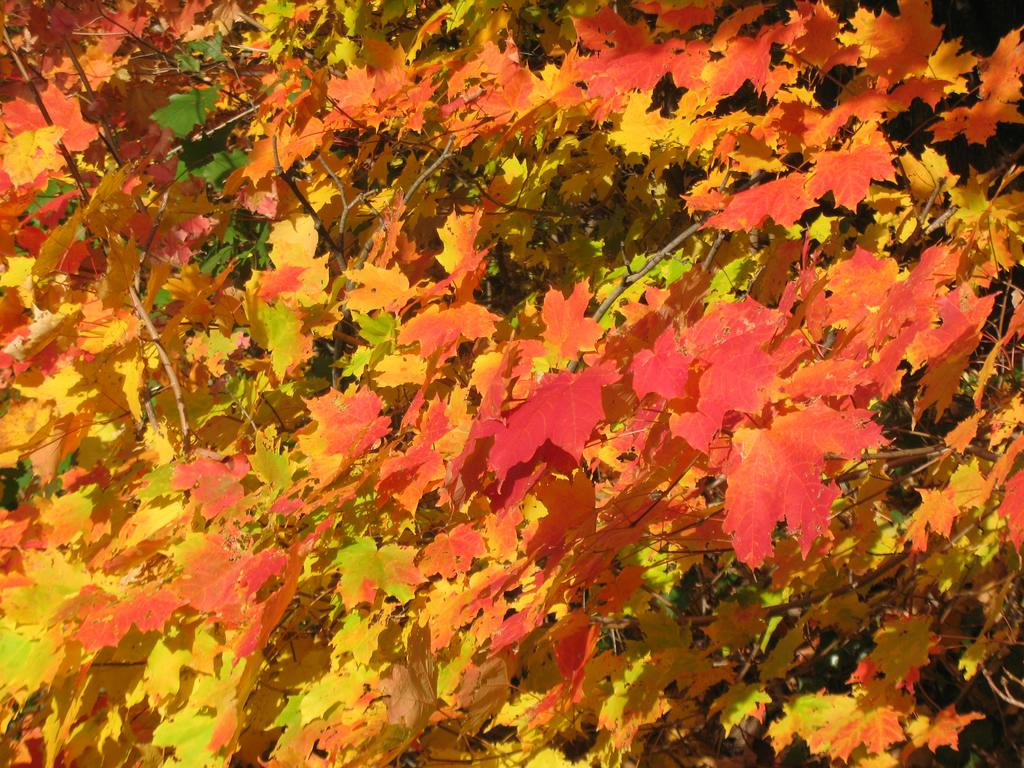What type of leaves are featured in the image? There are many maple leaves in the image. What is your sister doing in the quiet town in the image? There is no mention of a sister or a town in the image, as it only features maple leaves. 